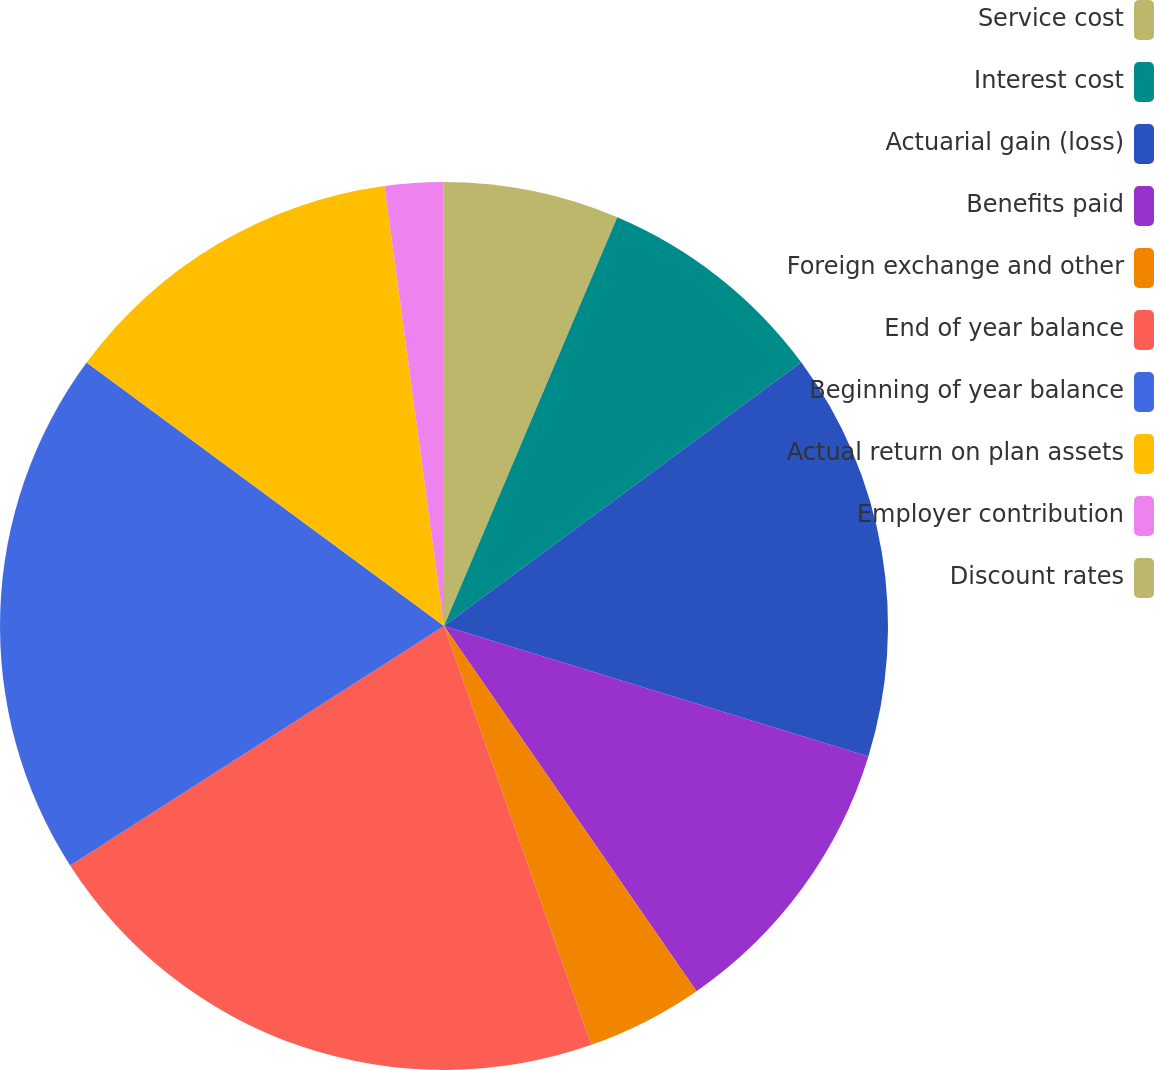Convert chart to OTSL. <chart><loc_0><loc_0><loc_500><loc_500><pie_chart><fcel>Service cost<fcel>Interest cost<fcel>Actuarial gain (loss)<fcel>Benefits paid<fcel>Foreign exchange and other<fcel>End of year balance<fcel>Beginning of year balance<fcel>Actual return on plan assets<fcel>Employer contribution<fcel>Discount rates<nl><fcel>6.38%<fcel>8.5%<fcel>14.87%<fcel>10.62%<fcel>4.25%<fcel>21.31%<fcel>19.18%<fcel>12.75%<fcel>2.13%<fcel>0.01%<nl></chart> 